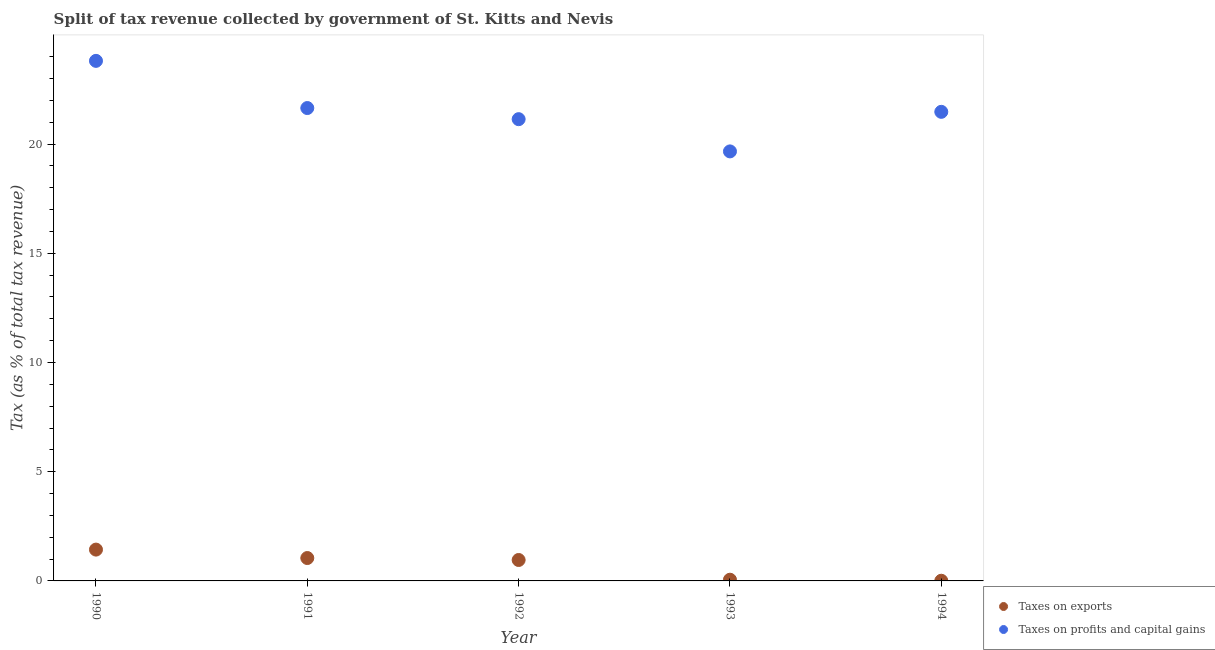How many different coloured dotlines are there?
Provide a succinct answer. 2. What is the percentage of revenue obtained from taxes on exports in 1994?
Give a very brief answer. 0.01. Across all years, what is the maximum percentage of revenue obtained from taxes on exports?
Your answer should be compact. 1.43. Across all years, what is the minimum percentage of revenue obtained from taxes on exports?
Keep it short and to the point. 0.01. In which year was the percentage of revenue obtained from taxes on exports maximum?
Your answer should be very brief. 1990. In which year was the percentage of revenue obtained from taxes on exports minimum?
Provide a succinct answer. 1994. What is the total percentage of revenue obtained from taxes on exports in the graph?
Offer a very short reply. 3.5. What is the difference between the percentage of revenue obtained from taxes on profits and capital gains in 1990 and that in 1991?
Make the answer very short. 2.16. What is the difference between the percentage of revenue obtained from taxes on exports in 1994 and the percentage of revenue obtained from taxes on profits and capital gains in 1992?
Provide a succinct answer. -21.13. What is the average percentage of revenue obtained from taxes on exports per year?
Keep it short and to the point. 0.7. In the year 1990, what is the difference between the percentage of revenue obtained from taxes on profits and capital gains and percentage of revenue obtained from taxes on exports?
Provide a succinct answer. 22.37. In how many years, is the percentage of revenue obtained from taxes on profits and capital gains greater than 12 %?
Your response must be concise. 5. What is the ratio of the percentage of revenue obtained from taxes on profits and capital gains in 1992 to that in 1993?
Keep it short and to the point. 1.08. Is the difference between the percentage of revenue obtained from taxes on profits and capital gains in 1990 and 1994 greater than the difference between the percentage of revenue obtained from taxes on exports in 1990 and 1994?
Your answer should be very brief. Yes. What is the difference between the highest and the second highest percentage of revenue obtained from taxes on profits and capital gains?
Provide a succinct answer. 2.16. What is the difference between the highest and the lowest percentage of revenue obtained from taxes on exports?
Give a very brief answer. 1.43. In how many years, is the percentage of revenue obtained from taxes on exports greater than the average percentage of revenue obtained from taxes on exports taken over all years?
Your answer should be very brief. 3. How many dotlines are there?
Your answer should be very brief. 2. What is the difference between two consecutive major ticks on the Y-axis?
Make the answer very short. 5. Are the values on the major ticks of Y-axis written in scientific E-notation?
Your answer should be compact. No. Does the graph contain grids?
Give a very brief answer. No. Where does the legend appear in the graph?
Your answer should be compact. Bottom right. How many legend labels are there?
Offer a very short reply. 2. What is the title of the graph?
Provide a short and direct response. Split of tax revenue collected by government of St. Kitts and Nevis. What is the label or title of the X-axis?
Offer a terse response. Year. What is the label or title of the Y-axis?
Your answer should be compact. Tax (as % of total tax revenue). What is the Tax (as % of total tax revenue) in Taxes on exports in 1990?
Make the answer very short. 1.43. What is the Tax (as % of total tax revenue) in Taxes on profits and capital gains in 1990?
Your answer should be compact. 23.81. What is the Tax (as % of total tax revenue) of Taxes on exports in 1991?
Provide a short and direct response. 1.05. What is the Tax (as % of total tax revenue) in Taxes on profits and capital gains in 1991?
Offer a terse response. 21.65. What is the Tax (as % of total tax revenue) in Taxes on exports in 1992?
Keep it short and to the point. 0.96. What is the Tax (as % of total tax revenue) of Taxes on profits and capital gains in 1992?
Provide a short and direct response. 21.14. What is the Tax (as % of total tax revenue) in Taxes on exports in 1993?
Keep it short and to the point. 0.06. What is the Tax (as % of total tax revenue) of Taxes on profits and capital gains in 1993?
Make the answer very short. 19.66. What is the Tax (as % of total tax revenue) of Taxes on exports in 1994?
Your answer should be compact. 0.01. What is the Tax (as % of total tax revenue) of Taxes on profits and capital gains in 1994?
Offer a very short reply. 21.47. Across all years, what is the maximum Tax (as % of total tax revenue) of Taxes on exports?
Your answer should be very brief. 1.43. Across all years, what is the maximum Tax (as % of total tax revenue) in Taxes on profits and capital gains?
Offer a terse response. 23.81. Across all years, what is the minimum Tax (as % of total tax revenue) in Taxes on exports?
Give a very brief answer. 0.01. Across all years, what is the minimum Tax (as % of total tax revenue) of Taxes on profits and capital gains?
Ensure brevity in your answer.  19.66. What is the total Tax (as % of total tax revenue) of Taxes on exports in the graph?
Make the answer very short. 3.5. What is the total Tax (as % of total tax revenue) in Taxes on profits and capital gains in the graph?
Your answer should be compact. 107.73. What is the difference between the Tax (as % of total tax revenue) in Taxes on exports in 1990 and that in 1991?
Keep it short and to the point. 0.39. What is the difference between the Tax (as % of total tax revenue) of Taxes on profits and capital gains in 1990 and that in 1991?
Your response must be concise. 2.16. What is the difference between the Tax (as % of total tax revenue) in Taxes on exports in 1990 and that in 1992?
Keep it short and to the point. 0.48. What is the difference between the Tax (as % of total tax revenue) in Taxes on profits and capital gains in 1990 and that in 1992?
Provide a short and direct response. 2.67. What is the difference between the Tax (as % of total tax revenue) of Taxes on exports in 1990 and that in 1993?
Offer a very short reply. 1.38. What is the difference between the Tax (as % of total tax revenue) in Taxes on profits and capital gains in 1990 and that in 1993?
Provide a succinct answer. 4.14. What is the difference between the Tax (as % of total tax revenue) in Taxes on exports in 1990 and that in 1994?
Provide a short and direct response. 1.43. What is the difference between the Tax (as % of total tax revenue) in Taxes on profits and capital gains in 1990 and that in 1994?
Your response must be concise. 2.33. What is the difference between the Tax (as % of total tax revenue) in Taxes on exports in 1991 and that in 1992?
Make the answer very short. 0.09. What is the difference between the Tax (as % of total tax revenue) of Taxes on profits and capital gains in 1991 and that in 1992?
Your answer should be compact. 0.51. What is the difference between the Tax (as % of total tax revenue) of Taxes on profits and capital gains in 1991 and that in 1993?
Keep it short and to the point. 1.98. What is the difference between the Tax (as % of total tax revenue) in Taxes on exports in 1991 and that in 1994?
Offer a terse response. 1.04. What is the difference between the Tax (as % of total tax revenue) of Taxes on profits and capital gains in 1991 and that in 1994?
Your answer should be compact. 0.17. What is the difference between the Tax (as % of total tax revenue) of Taxes on exports in 1992 and that in 1993?
Your answer should be very brief. 0.9. What is the difference between the Tax (as % of total tax revenue) in Taxes on profits and capital gains in 1992 and that in 1993?
Your answer should be very brief. 1.48. What is the difference between the Tax (as % of total tax revenue) of Taxes on exports in 1992 and that in 1994?
Offer a terse response. 0.95. What is the difference between the Tax (as % of total tax revenue) of Taxes on profits and capital gains in 1992 and that in 1994?
Your answer should be very brief. -0.34. What is the difference between the Tax (as % of total tax revenue) in Taxes on exports in 1993 and that in 1994?
Give a very brief answer. 0.05. What is the difference between the Tax (as % of total tax revenue) of Taxes on profits and capital gains in 1993 and that in 1994?
Give a very brief answer. -1.81. What is the difference between the Tax (as % of total tax revenue) of Taxes on exports in 1990 and the Tax (as % of total tax revenue) of Taxes on profits and capital gains in 1991?
Your answer should be very brief. -20.21. What is the difference between the Tax (as % of total tax revenue) of Taxes on exports in 1990 and the Tax (as % of total tax revenue) of Taxes on profits and capital gains in 1992?
Provide a succinct answer. -19.7. What is the difference between the Tax (as % of total tax revenue) in Taxes on exports in 1990 and the Tax (as % of total tax revenue) in Taxes on profits and capital gains in 1993?
Provide a short and direct response. -18.23. What is the difference between the Tax (as % of total tax revenue) in Taxes on exports in 1990 and the Tax (as % of total tax revenue) in Taxes on profits and capital gains in 1994?
Give a very brief answer. -20.04. What is the difference between the Tax (as % of total tax revenue) in Taxes on exports in 1991 and the Tax (as % of total tax revenue) in Taxes on profits and capital gains in 1992?
Your answer should be compact. -20.09. What is the difference between the Tax (as % of total tax revenue) in Taxes on exports in 1991 and the Tax (as % of total tax revenue) in Taxes on profits and capital gains in 1993?
Make the answer very short. -18.61. What is the difference between the Tax (as % of total tax revenue) of Taxes on exports in 1991 and the Tax (as % of total tax revenue) of Taxes on profits and capital gains in 1994?
Give a very brief answer. -20.43. What is the difference between the Tax (as % of total tax revenue) of Taxes on exports in 1992 and the Tax (as % of total tax revenue) of Taxes on profits and capital gains in 1993?
Ensure brevity in your answer.  -18.7. What is the difference between the Tax (as % of total tax revenue) of Taxes on exports in 1992 and the Tax (as % of total tax revenue) of Taxes on profits and capital gains in 1994?
Your response must be concise. -20.51. What is the difference between the Tax (as % of total tax revenue) of Taxes on exports in 1993 and the Tax (as % of total tax revenue) of Taxes on profits and capital gains in 1994?
Your answer should be compact. -21.42. What is the average Tax (as % of total tax revenue) of Taxes on exports per year?
Give a very brief answer. 0.7. What is the average Tax (as % of total tax revenue) of Taxes on profits and capital gains per year?
Make the answer very short. 21.55. In the year 1990, what is the difference between the Tax (as % of total tax revenue) in Taxes on exports and Tax (as % of total tax revenue) in Taxes on profits and capital gains?
Your response must be concise. -22.37. In the year 1991, what is the difference between the Tax (as % of total tax revenue) of Taxes on exports and Tax (as % of total tax revenue) of Taxes on profits and capital gains?
Give a very brief answer. -20.6. In the year 1992, what is the difference between the Tax (as % of total tax revenue) in Taxes on exports and Tax (as % of total tax revenue) in Taxes on profits and capital gains?
Your answer should be compact. -20.18. In the year 1993, what is the difference between the Tax (as % of total tax revenue) of Taxes on exports and Tax (as % of total tax revenue) of Taxes on profits and capital gains?
Give a very brief answer. -19.61. In the year 1994, what is the difference between the Tax (as % of total tax revenue) of Taxes on exports and Tax (as % of total tax revenue) of Taxes on profits and capital gains?
Offer a terse response. -21.46. What is the ratio of the Tax (as % of total tax revenue) in Taxes on exports in 1990 to that in 1991?
Your answer should be very brief. 1.37. What is the ratio of the Tax (as % of total tax revenue) of Taxes on profits and capital gains in 1990 to that in 1991?
Keep it short and to the point. 1.1. What is the ratio of the Tax (as % of total tax revenue) of Taxes on exports in 1990 to that in 1992?
Your response must be concise. 1.5. What is the ratio of the Tax (as % of total tax revenue) in Taxes on profits and capital gains in 1990 to that in 1992?
Make the answer very short. 1.13. What is the ratio of the Tax (as % of total tax revenue) in Taxes on exports in 1990 to that in 1993?
Offer a very short reply. 25.86. What is the ratio of the Tax (as % of total tax revenue) in Taxes on profits and capital gains in 1990 to that in 1993?
Provide a short and direct response. 1.21. What is the ratio of the Tax (as % of total tax revenue) in Taxes on exports in 1990 to that in 1994?
Provide a short and direct response. 174.21. What is the ratio of the Tax (as % of total tax revenue) of Taxes on profits and capital gains in 1990 to that in 1994?
Offer a terse response. 1.11. What is the ratio of the Tax (as % of total tax revenue) in Taxes on exports in 1991 to that in 1992?
Provide a succinct answer. 1.09. What is the ratio of the Tax (as % of total tax revenue) of Taxes on profits and capital gains in 1991 to that in 1992?
Provide a short and direct response. 1.02. What is the ratio of the Tax (as % of total tax revenue) in Taxes on exports in 1991 to that in 1993?
Make the answer very short. 18.9. What is the ratio of the Tax (as % of total tax revenue) of Taxes on profits and capital gains in 1991 to that in 1993?
Ensure brevity in your answer.  1.1. What is the ratio of the Tax (as % of total tax revenue) in Taxes on exports in 1991 to that in 1994?
Your answer should be very brief. 127.31. What is the ratio of the Tax (as % of total tax revenue) in Taxes on exports in 1992 to that in 1993?
Provide a succinct answer. 17.29. What is the ratio of the Tax (as % of total tax revenue) in Taxes on profits and capital gains in 1992 to that in 1993?
Provide a succinct answer. 1.07. What is the ratio of the Tax (as % of total tax revenue) in Taxes on exports in 1992 to that in 1994?
Your answer should be very brief. 116.45. What is the ratio of the Tax (as % of total tax revenue) of Taxes on profits and capital gains in 1992 to that in 1994?
Your answer should be very brief. 0.98. What is the ratio of the Tax (as % of total tax revenue) in Taxes on exports in 1993 to that in 1994?
Keep it short and to the point. 6.74. What is the ratio of the Tax (as % of total tax revenue) of Taxes on profits and capital gains in 1993 to that in 1994?
Your answer should be compact. 0.92. What is the difference between the highest and the second highest Tax (as % of total tax revenue) of Taxes on exports?
Your answer should be compact. 0.39. What is the difference between the highest and the second highest Tax (as % of total tax revenue) in Taxes on profits and capital gains?
Your answer should be compact. 2.16. What is the difference between the highest and the lowest Tax (as % of total tax revenue) in Taxes on exports?
Give a very brief answer. 1.43. What is the difference between the highest and the lowest Tax (as % of total tax revenue) in Taxes on profits and capital gains?
Provide a succinct answer. 4.14. 